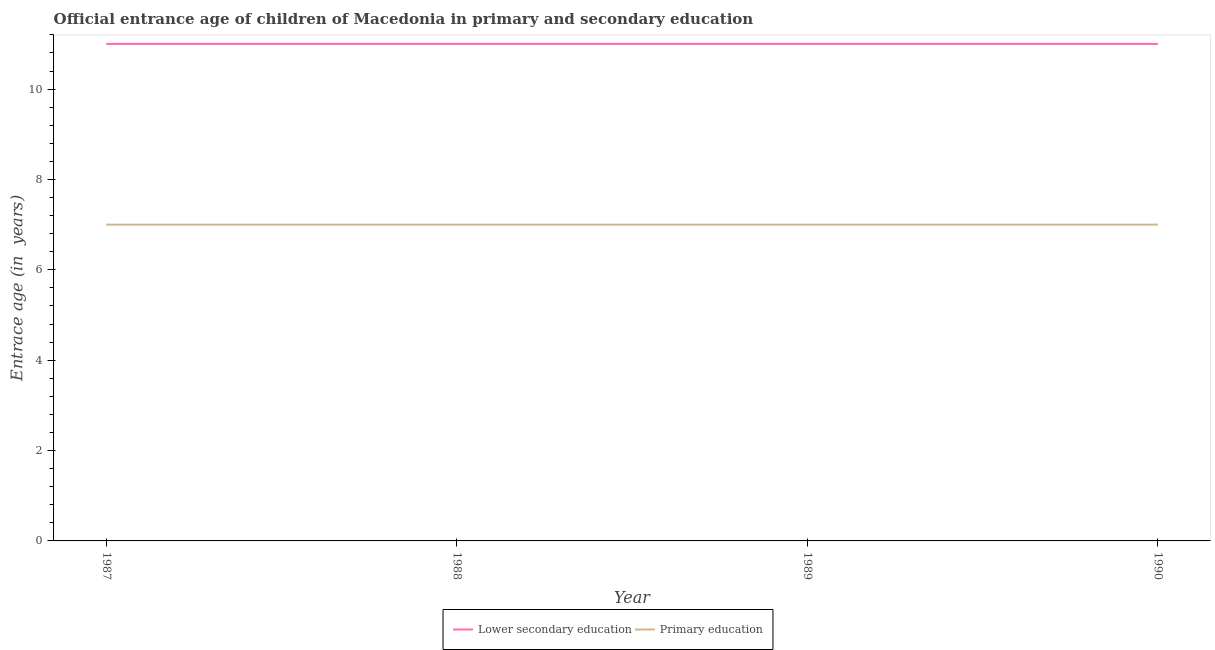How many different coloured lines are there?
Make the answer very short. 2. Does the line corresponding to entrance age of children in lower secondary education intersect with the line corresponding to entrance age of chiildren in primary education?
Give a very brief answer. No. What is the entrance age of chiildren in primary education in 1987?
Provide a short and direct response. 7. Across all years, what is the maximum entrance age of chiildren in primary education?
Provide a short and direct response. 7. Across all years, what is the minimum entrance age of children in lower secondary education?
Keep it short and to the point. 11. In which year was the entrance age of children in lower secondary education minimum?
Ensure brevity in your answer.  1987. What is the total entrance age of chiildren in primary education in the graph?
Your answer should be compact. 28. What is the difference between the entrance age of chiildren in primary education in 1988 and the entrance age of children in lower secondary education in 1987?
Make the answer very short. -4. In the year 1988, what is the difference between the entrance age of children in lower secondary education and entrance age of chiildren in primary education?
Offer a very short reply. 4. In how many years, is the entrance age of chiildren in primary education greater than 0.8 years?
Your response must be concise. 4. What is the ratio of the entrance age of chiildren in primary education in 1988 to that in 1990?
Make the answer very short. 1. Is the difference between the entrance age of chiildren in primary education in 1987 and 1990 greater than the difference between the entrance age of children in lower secondary education in 1987 and 1990?
Offer a very short reply. No. In how many years, is the entrance age of children in lower secondary education greater than the average entrance age of children in lower secondary education taken over all years?
Offer a very short reply. 0. Is the sum of the entrance age of children in lower secondary education in 1988 and 1989 greater than the maximum entrance age of chiildren in primary education across all years?
Give a very brief answer. Yes. Is the entrance age of children in lower secondary education strictly greater than the entrance age of chiildren in primary education over the years?
Provide a short and direct response. Yes. Is the entrance age of chiildren in primary education strictly less than the entrance age of children in lower secondary education over the years?
Offer a terse response. Yes. How many years are there in the graph?
Your response must be concise. 4. Are the values on the major ticks of Y-axis written in scientific E-notation?
Offer a very short reply. No. Does the graph contain any zero values?
Keep it short and to the point. No. Where does the legend appear in the graph?
Your response must be concise. Bottom center. How many legend labels are there?
Provide a short and direct response. 2. How are the legend labels stacked?
Keep it short and to the point. Horizontal. What is the title of the graph?
Your answer should be very brief. Official entrance age of children of Macedonia in primary and secondary education. Does "constant 2005 US$" appear as one of the legend labels in the graph?
Provide a succinct answer. No. What is the label or title of the X-axis?
Your response must be concise. Year. What is the label or title of the Y-axis?
Your answer should be compact. Entrace age (in  years). What is the Entrace age (in  years) in Lower secondary education in 1988?
Make the answer very short. 11. What is the Entrace age (in  years) of Primary education in 1988?
Make the answer very short. 7. What is the Entrace age (in  years) of Primary education in 1989?
Your answer should be compact. 7. Across all years, what is the maximum Entrace age (in  years) of Primary education?
Your answer should be compact. 7. Across all years, what is the minimum Entrace age (in  years) in Lower secondary education?
Provide a succinct answer. 11. What is the difference between the Entrace age (in  years) in Lower secondary education in 1987 and that in 1988?
Your response must be concise. 0. What is the difference between the Entrace age (in  years) in Primary education in 1987 and that in 1988?
Your response must be concise. 0. What is the difference between the Entrace age (in  years) of Lower secondary education in 1987 and that in 1989?
Provide a short and direct response. 0. What is the difference between the Entrace age (in  years) of Lower secondary education in 1987 and that in 1990?
Your answer should be compact. 0. What is the difference between the Entrace age (in  years) of Lower secondary education in 1988 and that in 1989?
Provide a succinct answer. 0. What is the difference between the Entrace age (in  years) in Lower secondary education in 1987 and the Entrace age (in  years) in Primary education in 1989?
Offer a terse response. 4. What is the difference between the Entrace age (in  years) of Lower secondary education in 1987 and the Entrace age (in  years) of Primary education in 1990?
Your answer should be very brief. 4. What is the ratio of the Entrace age (in  years) of Lower secondary education in 1987 to that in 1988?
Offer a terse response. 1. What is the ratio of the Entrace age (in  years) in Primary education in 1987 to that in 1989?
Your answer should be very brief. 1. What is the ratio of the Entrace age (in  years) of Lower secondary education in 1987 to that in 1990?
Provide a short and direct response. 1. What is the ratio of the Entrace age (in  years) of Primary education in 1987 to that in 1990?
Your answer should be very brief. 1. What is the difference between the highest and the second highest Entrace age (in  years) in Lower secondary education?
Ensure brevity in your answer.  0. What is the difference between the highest and the second highest Entrace age (in  years) in Primary education?
Your response must be concise. 0. What is the difference between the highest and the lowest Entrace age (in  years) of Primary education?
Give a very brief answer. 0. 